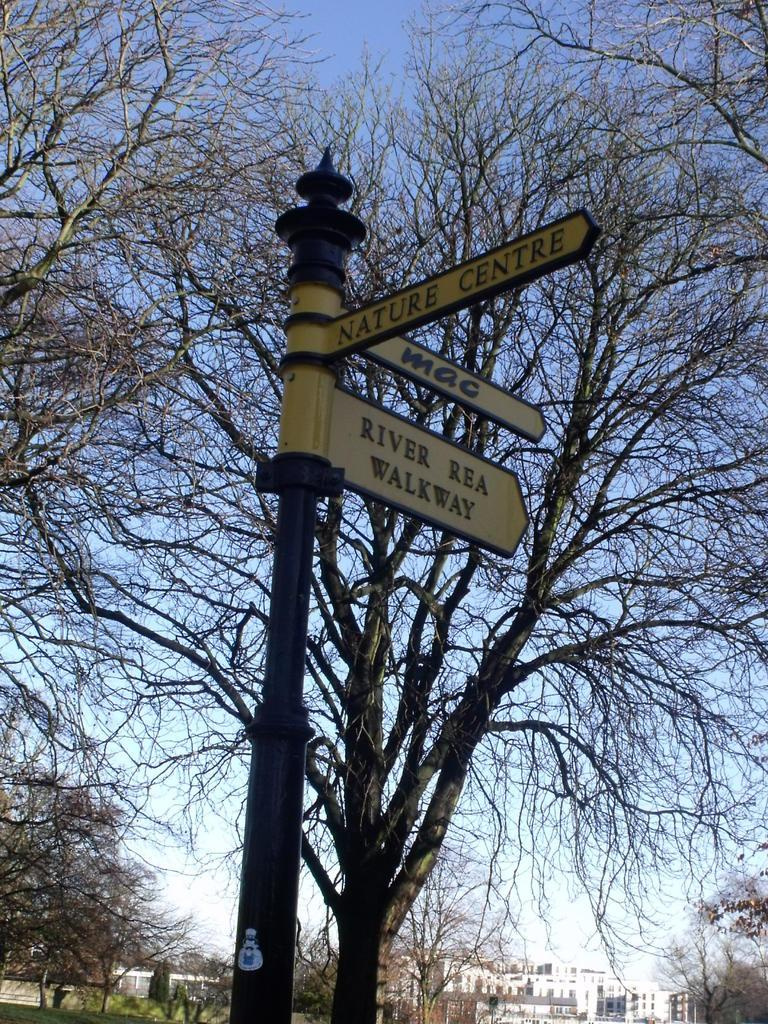What is the main object in the image? There is a pole in the image. What is attached to the pole? Sign boards are attached to the pole. What information is provided on the sign boards? There is text written on the sign boards. What can be seen in the background of the image? There are trees, buildings, and the sky visible in the background of the image. How many doors can be seen in the image? There are no doors visible in the image. What type of sorting activity is taking place in the image? There is no sorting activity present in the image. 